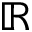Convert formula to latex. <formula><loc_0><loc_0><loc_500><loc_500>\mathbb { R }</formula> 